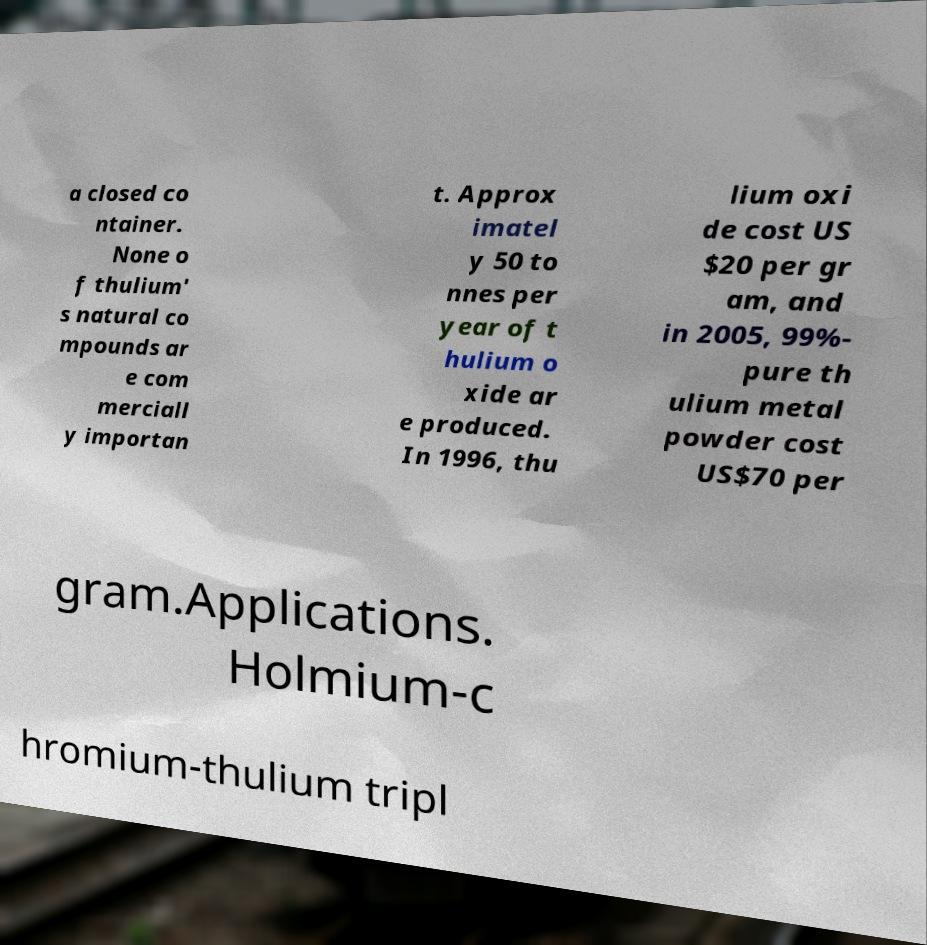Can you read and provide the text displayed in the image?This photo seems to have some interesting text. Can you extract and type it out for me? a closed co ntainer. None o f thulium' s natural co mpounds ar e com merciall y importan t. Approx imatel y 50 to nnes per year of t hulium o xide ar e produced. In 1996, thu lium oxi de cost US $20 per gr am, and in 2005, 99%- pure th ulium metal powder cost US$70 per gram.Applications. Holmium-c hromium-thulium tripl 